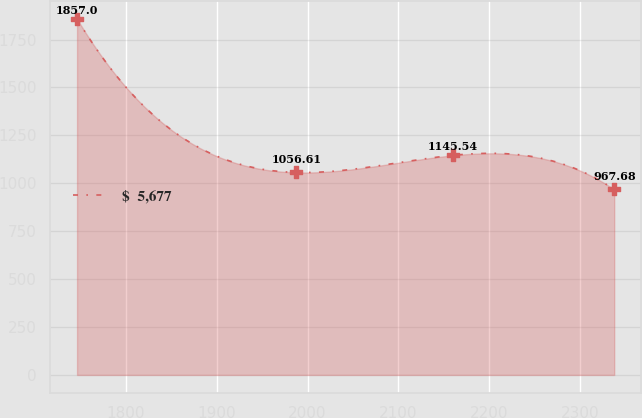Convert chart. <chart><loc_0><loc_0><loc_500><loc_500><line_chart><ecel><fcel>$  5,677<nl><fcel>1746.62<fcel>1857<nl><fcel>1987.86<fcel>1056.61<nl><fcel>2159.47<fcel>1145.54<nl><fcel>2337.21<fcel>967.68<nl></chart> 